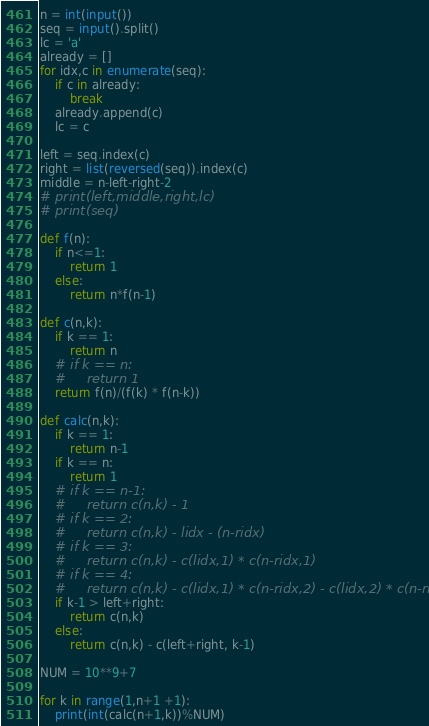<code> <loc_0><loc_0><loc_500><loc_500><_Python_>n = int(input())
seq = input().split()
lc = 'a'
already = []
for idx,c in enumerate(seq):
    if c in already:
        break
    already.append(c)
    lc = c

left = seq.index(c)
right = list(reversed(seq)).index(c)
middle = n-left-right-2
# print(left,middle,right,lc)
# print(seq)

def f(n):
    if n<=1:
        return 1
    else:
        return n*f(n-1)

def c(n,k):
    if k == 1:
        return n
    # if k == n:
    #     return 1
    return f(n)/(f(k) * f(n-k))

def calc(n,k):
    if k == 1:
        return n-1
    if k == n:
        return 1
    # if k == n-1:
    #     return c(n,k) - 1
    # if k == 2:
    #     return c(n,k) - lidx - (n-ridx)
    # if k == 3:
    #     return c(n,k) - c(lidx,1) * c(n-ridx,1)
    # if k == 4:
    #     return c(n,k) - c(lidx,1) * c(n-ridx,2) - c(lidx,2) * c(n-ridx,1)
    if k-1 > left+right:
        return c(n,k)
    else:
        return c(n,k) - c(left+right, k-1)

NUM = 10**9+7

for k in range(1,n+1 +1):
    print(int(calc(n+1,k))%NUM)
</code> 